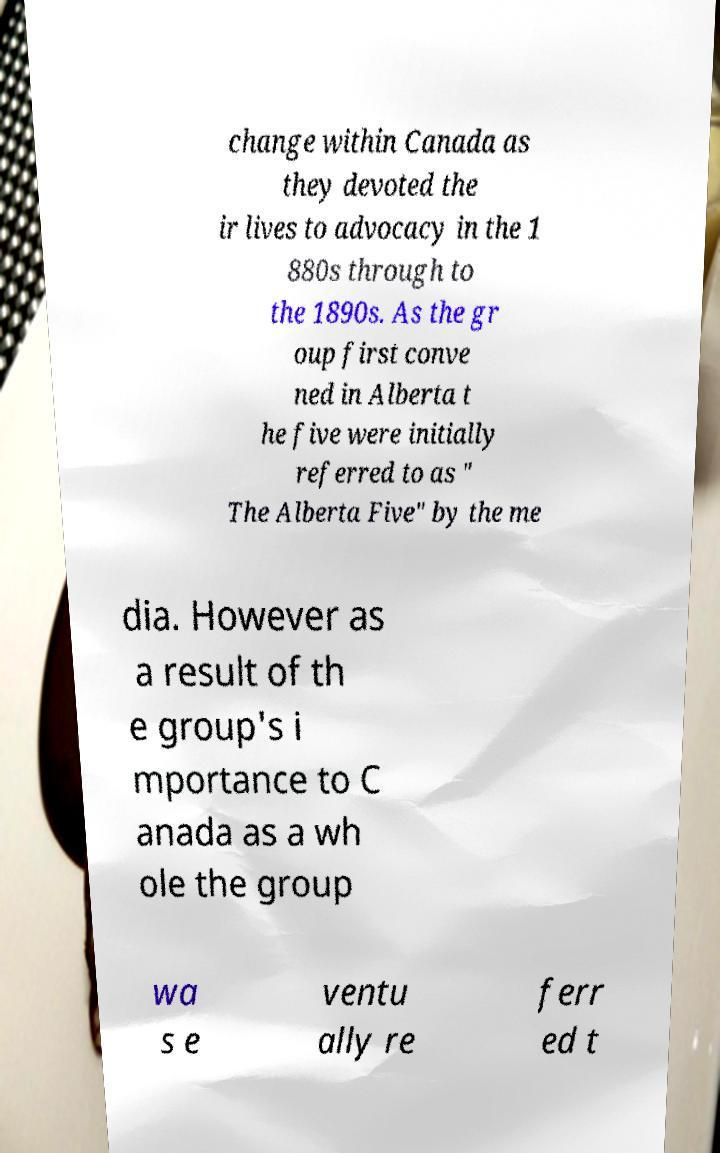For documentation purposes, I need the text within this image transcribed. Could you provide that? change within Canada as they devoted the ir lives to advocacy in the 1 880s through to the 1890s. As the gr oup first conve ned in Alberta t he five were initially referred to as " The Alberta Five" by the me dia. However as a result of th e group's i mportance to C anada as a wh ole the group wa s e ventu ally re ferr ed t 